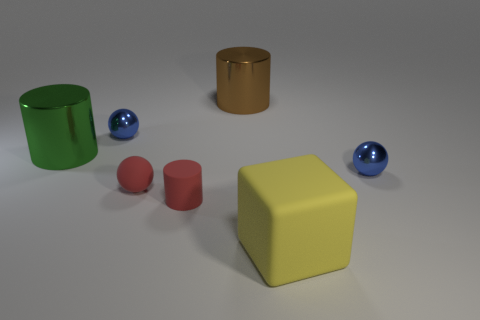Add 3 big green things. How many objects exist? 10 Subtract all blocks. How many objects are left? 6 Add 3 big brown metal cylinders. How many big brown metal cylinders are left? 4 Add 6 large metallic cylinders. How many large metallic cylinders exist? 8 Subtract 0 gray cylinders. How many objects are left? 7 Subtract all red cylinders. Subtract all rubber spheres. How many objects are left? 5 